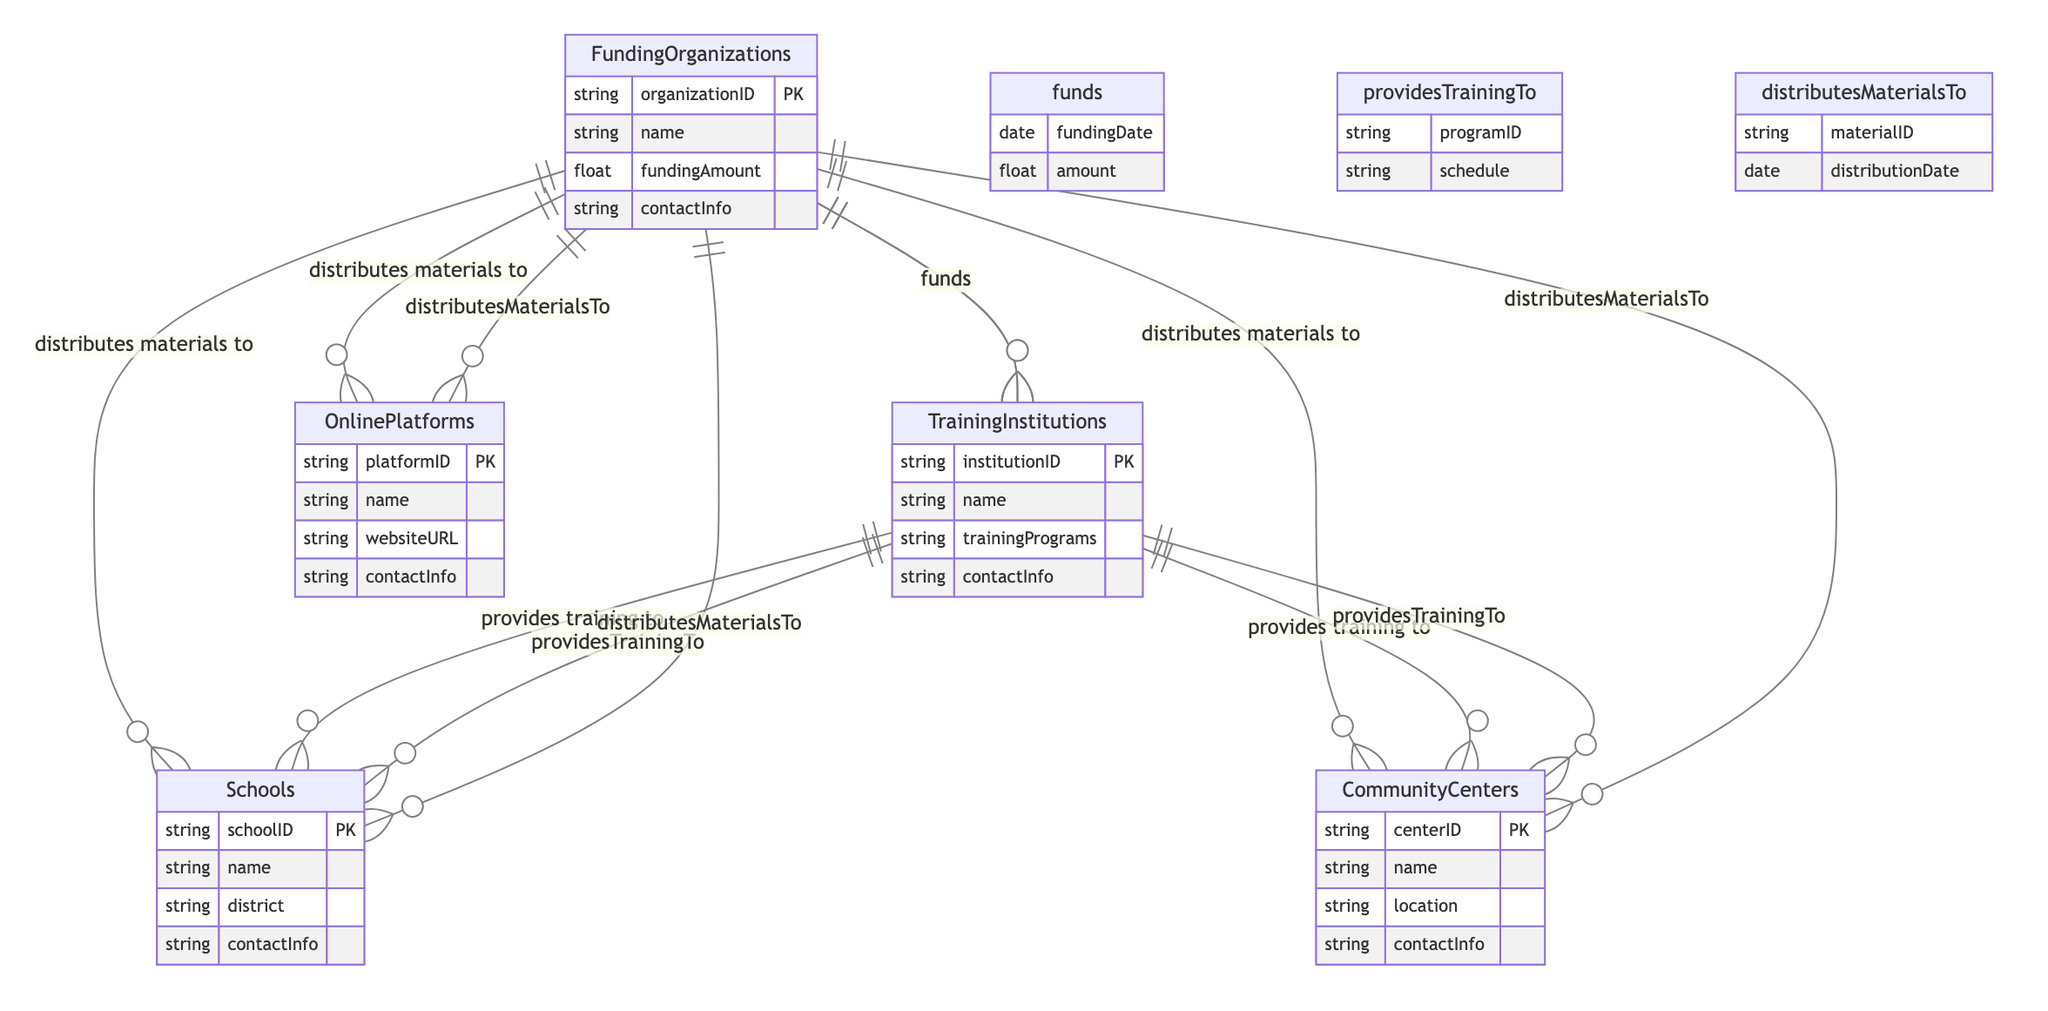What entities are involved in resource allocation? The entities listed in the diagram include Funding Organizations, Training Institutions, Schools, Community Centers, and Online Platforms.
Answer: Funding Organizations, Training Institutions, Schools, Community Centers, Online Platforms How many relationships are there in the diagram? By counting the relationships between entities, we can find that there are a total of 6 relationships depicted.
Answer: 6 What does the Funding Organizations entity distribute to Community Centers? The Funding Organizations entity distributes materials to Community Centers as part of their resource allocation efforts.
Answer: Materials Which entity provides training to Schools? The entity that provides training to Schools is the Training Institutions, indicating their role in offering educational programs.
Answer: Training Institutions What type of relationship exists between Funding Organizations and Training Institutions? The relationship between Funding Organizations and Training Institutions is termed as "funds," showing that one entity finances the other.
Answer: Funds How many attributes are associated with the Schools entity? The Schools entity has 4 attributes associated with it: schoolID, name, district, and contactInfo.
Answer: 4 What material distribution action occurs on a specific date? The distribution of materials to various entities, including Schools, Community Centers, and Online Platforms, occurs on a specific distribution date.
Answer: Distribution Date Which institutions provide training to Community Centers? Training Institutions provide training to Community Centers, reflecting the collaborative effort to educate community members about human trafficking prevention.
Answer: Training Institutions What kind of information is obtained from the Funding Organizations entity? The Funding Organizations entity provides information such as organizationID, name, fundingAmount, and contactInfo.
Answer: Organization ID, name, funding amount, contact info What is the relationship between Training Institutions and Schools called? The relationship between Training Institutions and Schools is called "provides training to," indicating the educational initiative taken by Training Institutions.
Answer: Provides training to 